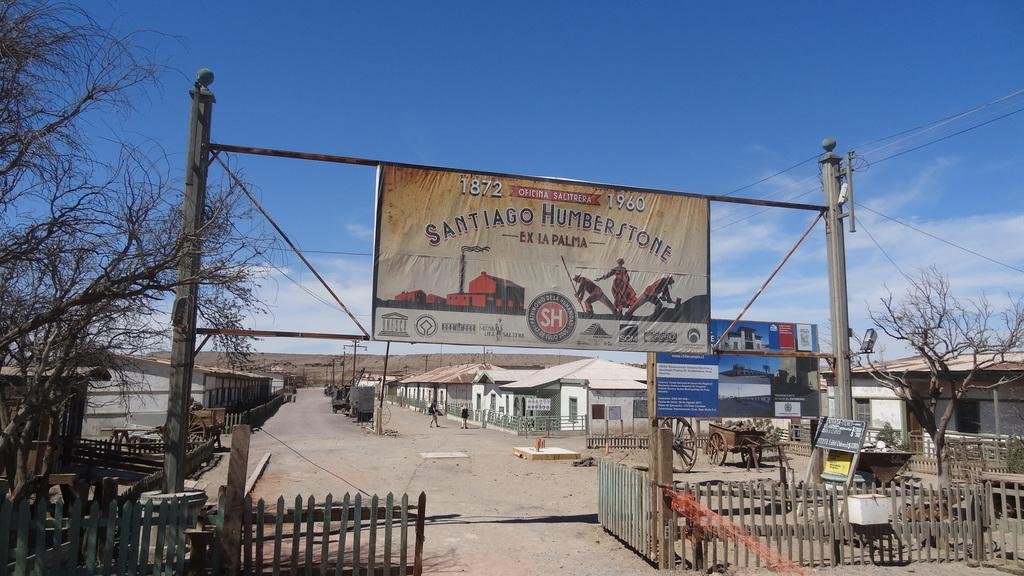<image>
Render a clear and concise summary of the photo. Banner hanging that says the year 1872 on it. 